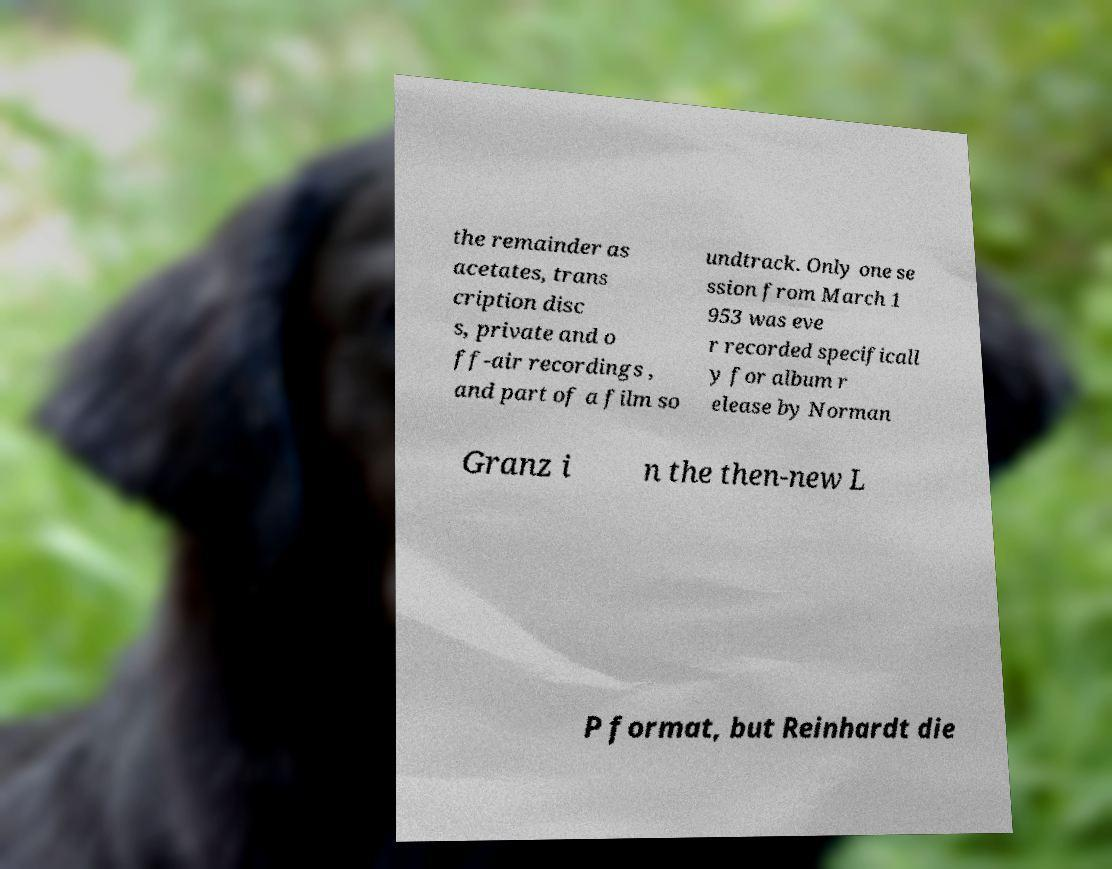Could you assist in decoding the text presented in this image and type it out clearly? the remainder as acetates, trans cription disc s, private and o ff-air recordings , and part of a film so undtrack. Only one se ssion from March 1 953 was eve r recorded specificall y for album r elease by Norman Granz i n the then-new L P format, but Reinhardt die 